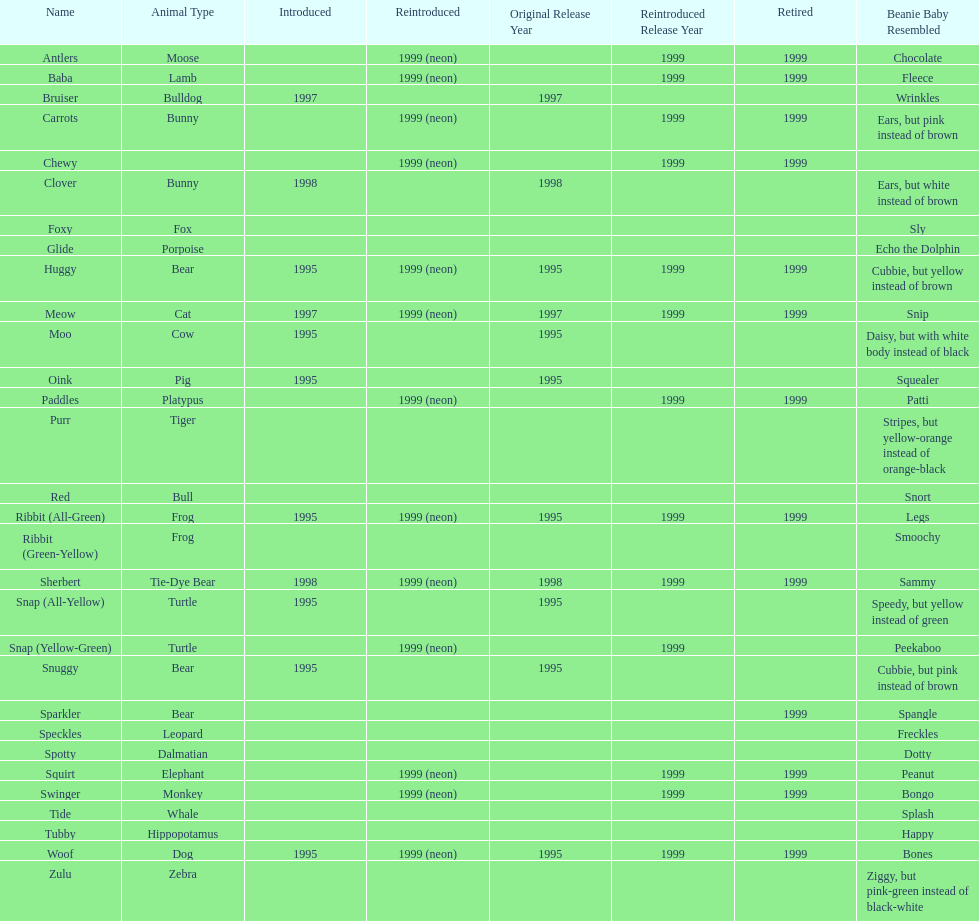What is the number of frog pillow pals? 2. 